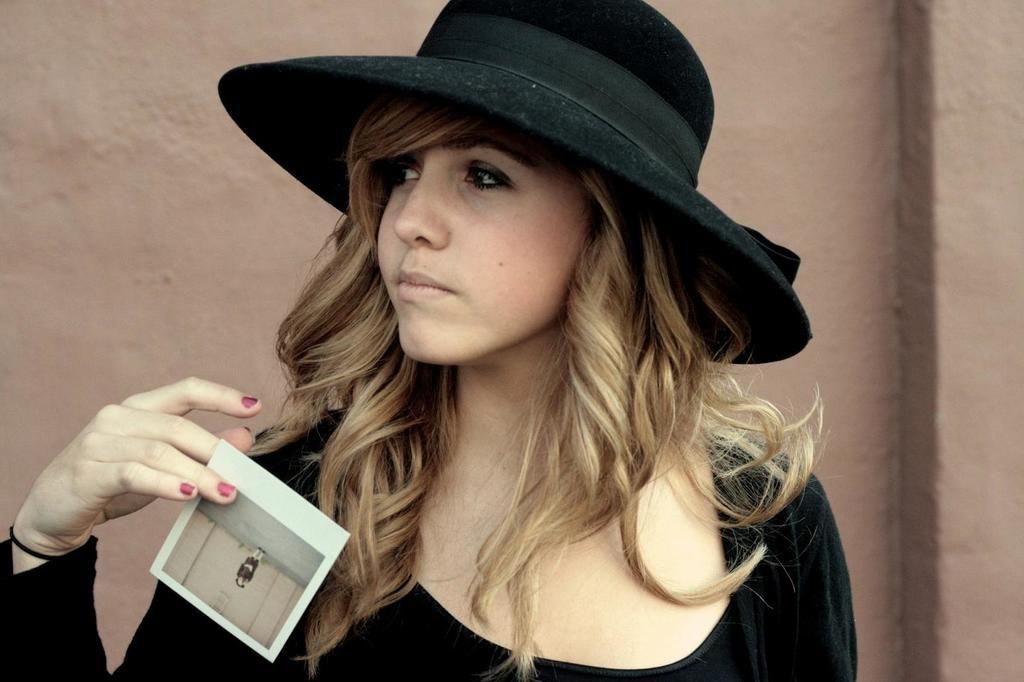Who or what is present in the image? There is a person in the image. Can you describe the person's attire? The person is wearing a hat. What is the person holding in the image? The person is holding an object. What can be seen in the background of the image? There is a wall in the background of the image. How many ants are crawling on the person's hat in the image? There are no ants present in the image; the person is wearing a hat, but there are no ants visible. 